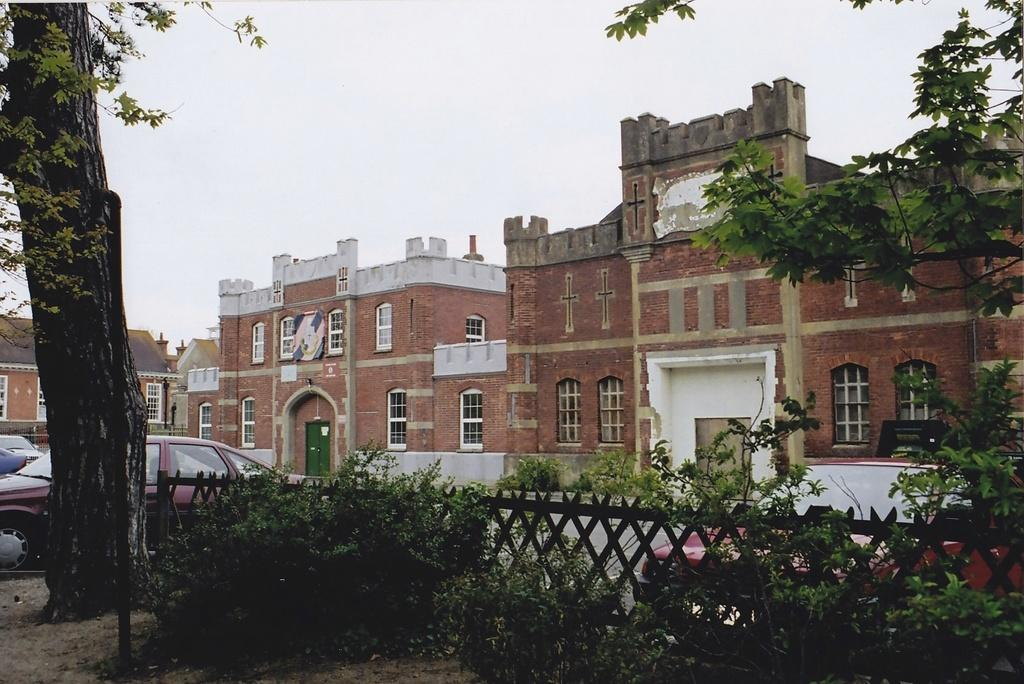What type of barrier can be seen in the image? There is fencing in the image. What is located in front of the fencing? There are plants in front of the fencing. What type of vegetation is visible in the image? There are trees visible in the image. What type of vehicles are present in front of the fencing? Cars are present in front of the fencing. What can be seen in the background of the image? There are buildings and the sky visible in the background of the image. What type of can is visible on the canvas in the image? There is no can or canvas present in the image. 